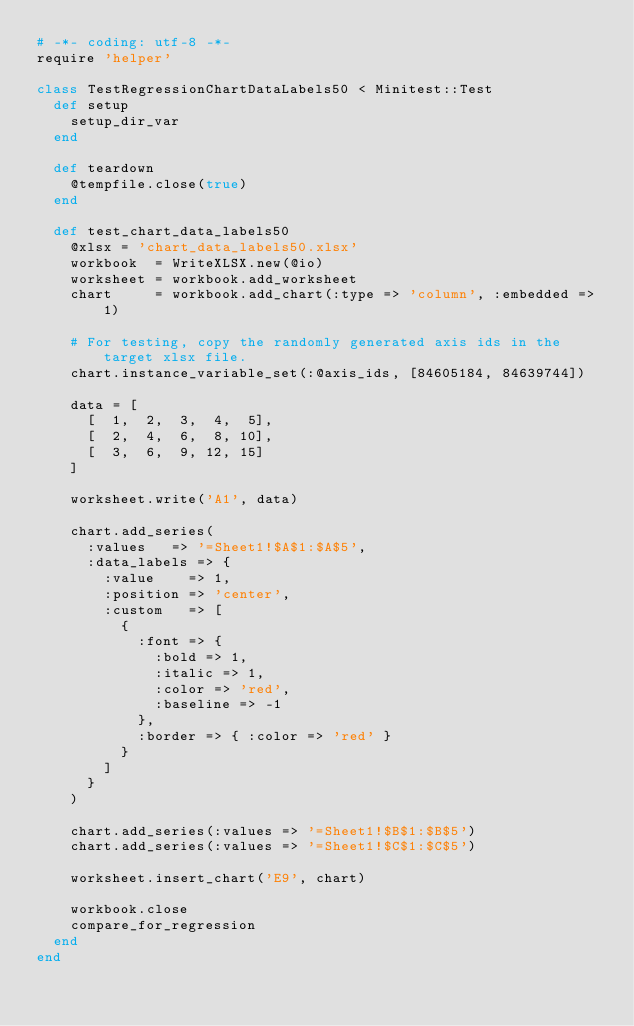<code> <loc_0><loc_0><loc_500><loc_500><_Ruby_># -*- coding: utf-8 -*-
require 'helper'

class TestRegressionChartDataLabels50 < Minitest::Test
  def setup
    setup_dir_var
  end

  def teardown
    @tempfile.close(true)
  end

  def test_chart_data_labels50
    @xlsx = 'chart_data_labels50.xlsx'
    workbook  = WriteXLSX.new(@io)
    worksheet = workbook.add_worksheet
    chart     = workbook.add_chart(:type => 'column', :embedded => 1)

    # For testing, copy the randomly generated axis ids in the target xlsx file.
    chart.instance_variable_set(:@axis_ids, [84605184, 84639744])

    data = [
      [  1,  2,  3,  4,  5],
      [  2,  4,  6,  8, 10],
      [  3,  6,  9, 12, 15]
    ]

    worksheet.write('A1', data)

    chart.add_series(
      :values   => '=Sheet1!$A$1:$A$5',
      :data_labels => {
        :value    => 1,
        :position => 'center',
        :custom   => [
          {
            :font => {
              :bold => 1,
              :italic => 1,
              :color => 'red',
              :baseline => -1
            },
            :border => { :color => 'red' }
          }
        ]
      }
    )

    chart.add_series(:values => '=Sheet1!$B$1:$B$5')
    chart.add_series(:values => '=Sheet1!$C$1:$C$5')

    worksheet.insert_chart('E9', chart)

    workbook.close
    compare_for_regression
  end
end
</code> 